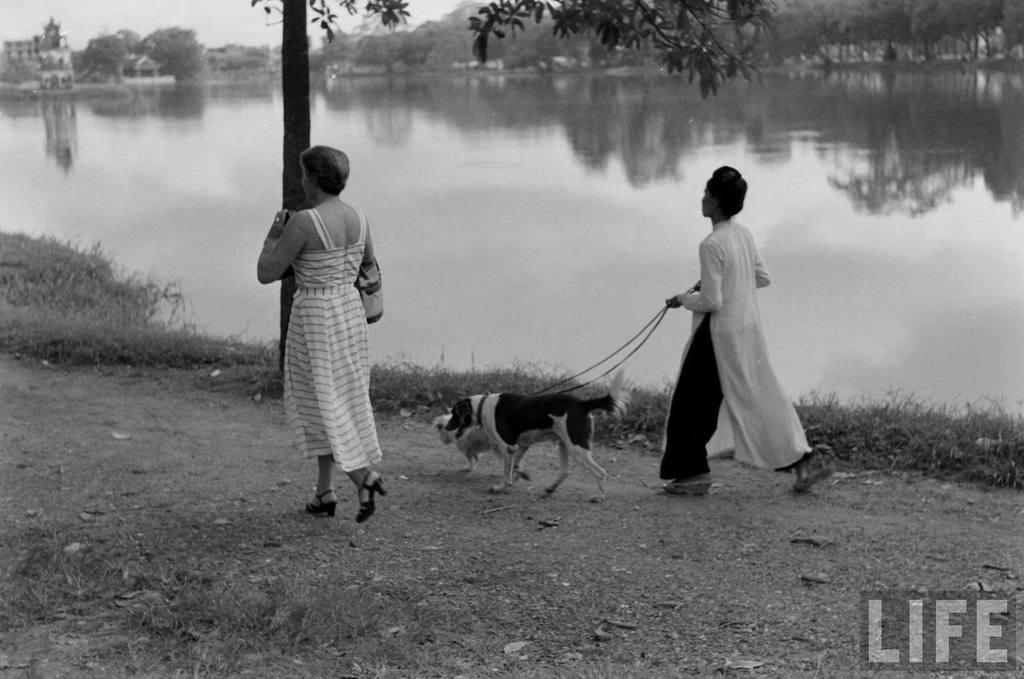How many women are present in the image? There are 2 women in the image. What is one of the women doing with the dogs? One of the women is holding the ropes of the dogs. What can be seen in the image besides the women and dogs? There is a tree in the image. What is visible in the background of the image? There is water and many trees visible in the background. What direction are the dogs coiled in the image? There are no dogs coiled in the image; the woman is holding the ropes of the dogs. 